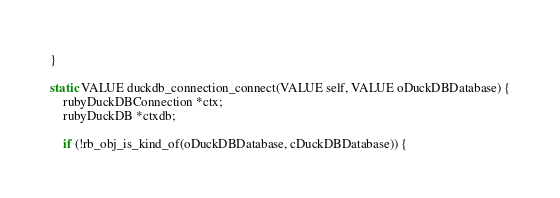Convert code to text. <code><loc_0><loc_0><loc_500><loc_500><_C_>}

static VALUE duckdb_connection_connect(VALUE self, VALUE oDuckDBDatabase) {
    rubyDuckDBConnection *ctx;
    rubyDuckDB *ctxdb;

    if (!rb_obj_is_kind_of(oDuckDBDatabase, cDuckDBDatabase)) {</code> 